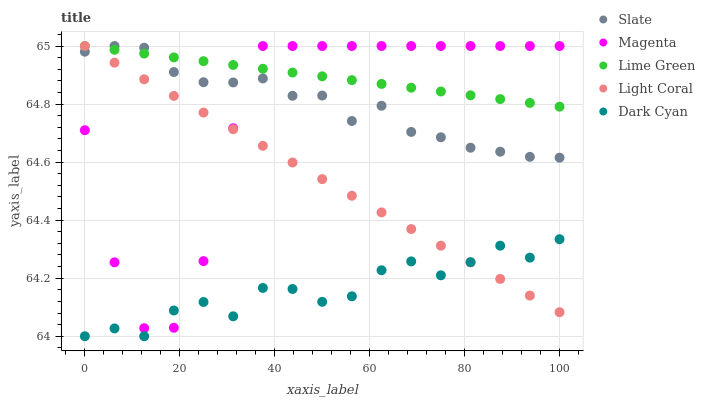Does Dark Cyan have the minimum area under the curve?
Answer yes or no. Yes. Does Lime Green have the maximum area under the curve?
Answer yes or no. Yes. Does Slate have the minimum area under the curve?
Answer yes or no. No. Does Slate have the maximum area under the curve?
Answer yes or no. No. Is Light Coral the smoothest?
Answer yes or no. Yes. Is Magenta the roughest?
Answer yes or no. Yes. Is Dark Cyan the smoothest?
Answer yes or no. No. Is Dark Cyan the roughest?
Answer yes or no. No. Does Dark Cyan have the lowest value?
Answer yes or no. Yes. Does Slate have the lowest value?
Answer yes or no. No. Does Magenta have the highest value?
Answer yes or no. Yes. Does Dark Cyan have the highest value?
Answer yes or no. No. Is Dark Cyan less than Lime Green?
Answer yes or no. Yes. Is Slate greater than Dark Cyan?
Answer yes or no. Yes. Does Dark Cyan intersect Magenta?
Answer yes or no. Yes. Is Dark Cyan less than Magenta?
Answer yes or no. No. Is Dark Cyan greater than Magenta?
Answer yes or no. No. Does Dark Cyan intersect Lime Green?
Answer yes or no. No. 